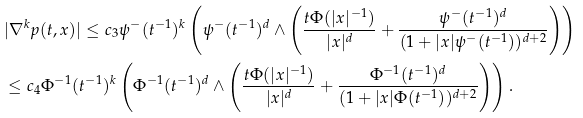<formula> <loc_0><loc_0><loc_500><loc_500>& | \nabla ^ { k } p ( t , x ) | \leq c _ { 3 } \psi ^ { - } ( t ^ { - 1 } ) ^ { k } \left ( \psi ^ { - } ( t ^ { - 1 } ) ^ { d } \wedge \left ( \frac { t \Phi ( | x | ^ { - 1 } ) } { | x | ^ { d } } + \frac { \psi ^ { - } ( t ^ { - 1 } ) ^ { d } } { ( 1 + | x | \psi ^ { - } ( t ^ { - 1 } ) ) ^ { d + 2 } } \right ) \right ) \\ & \leq c _ { 4 } \Phi ^ { - 1 } ( t ^ { - 1 } ) ^ { k } \left ( \Phi ^ { - 1 } ( t ^ { - 1 } ) ^ { d } \wedge \left ( \frac { t \Phi ( | x | ^ { - 1 } ) } { | x | ^ { d } } + \frac { \Phi ^ { - 1 } ( t ^ { - 1 } ) ^ { d } } { ( 1 + | x | \Phi ( t ^ { - 1 } ) ) ^ { d + 2 } } \right ) \right ) .</formula> 